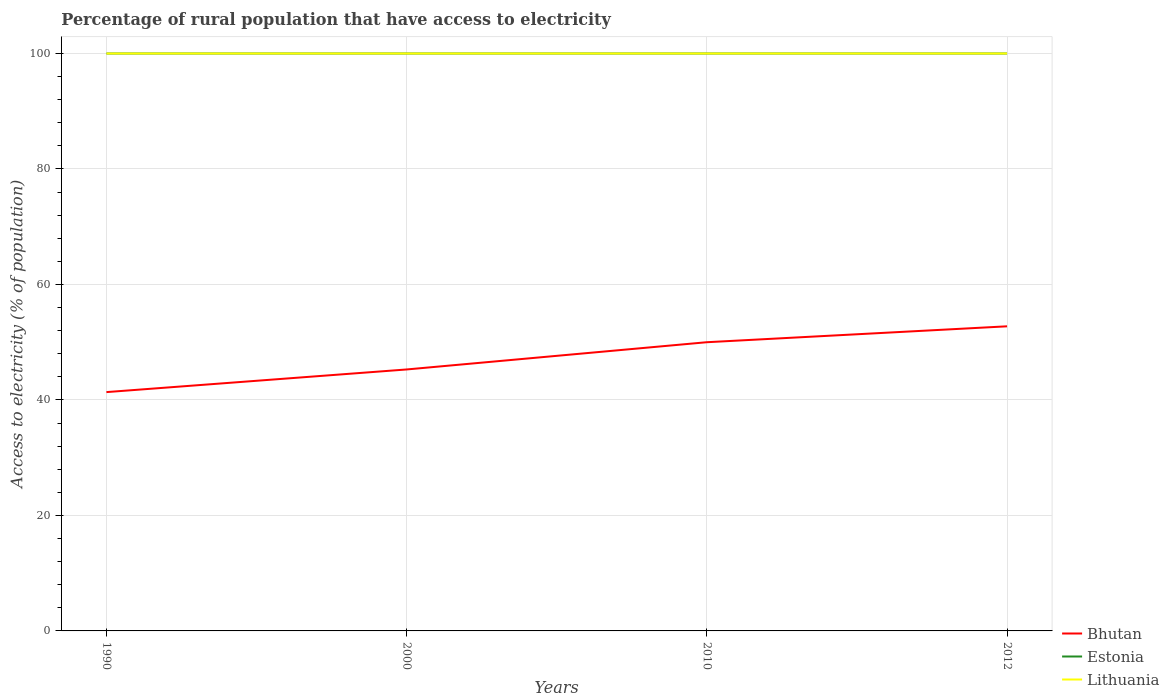Does the line corresponding to Bhutan intersect with the line corresponding to Lithuania?
Ensure brevity in your answer.  No. Across all years, what is the maximum percentage of rural population that have access to electricity in Lithuania?
Make the answer very short. 100. In which year was the percentage of rural population that have access to electricity in Bhutan maximum?
Offer a very short reply. 1990. What is the total percentage of rural population that have access to electricity in Estonia in the graph?
Provide a succinct answer. 0. Is the percentage of rural population that have access to electricity in Lithuania strictly greater than the percentage of rural population that have access to electricity in Bhutan over the years?
Your answer should be very brief. No. How many lines are there?
Make the answer very short. 3. How many years are there in the graph?
Keep it short and to the point. 4. What is the difference between two consecutive major ticks on the Y-axis?
Provide a short and direct response. 20. What is the title of the graph?
Give a very brief answer. Percentage of rural population that have access to electricity. What is the label or title of the X-axis?
Your answer should be very brief. Years. What is the label or title of the Y-axis?
Your answer should be compact. Access to electricity (% of population). What is the Access to electricity (% of population) in Bhutan in 1990?
Offer a very short reply. 41.36. What is the Access to electricity (% of population) in Estonia in 1990?
Make the answer very short. 100. What is the Access to electricity (% of population) of Bhutan in 2000?
Your answer should be compact. 45.28. What is the Access to electricity (% of population) in Lithuania in 2000?
Offer a very short reply. 100. What is the Access to electricity (% of population) in Bhutan in 2010?
Your answer should be compact. 50. What is the Access to electricity (% of population) of Estonia in 2010?
Provide a short and direct response. 100. What is the Access to electricity (% of population) of Bhutan in 2012?
Provide a short and direct response. 52.75. What is the Access to electricity (% of population) in Lithuania in 2012?
Ensure brevity in your answer.  100. Across all years, what is the maximum Access to electricity (% of population) in Bhutan?
Keep it short and to the point. 52.75. Across all years, what is the maximum Access to electricity (% of population) in Lithuania?
Make the answer very short. 100. Across all years, what is the minimum Access to electricity (% of population) in Bhutan?
Provide a succinct answer. 41.36. What is the total Access to electricity (% of population) in Bhutan in the graph?
Your answer should be compact. 189.4. What is the total Access to electricity (% of population) in Estonia in the graph?
Offer a terse response. 400. What is the total Access to electricity (% of population) in Lithuania in the graph?
Offer a terse response. 400. What is the difference between the Access to electricity (% of population) of Bhutan in 1990 and that in 2000?
Make the answer very short. -3.92. What is the difference between the Access to electricity (% of population) in Estonia in 1990 and that in 2000?
Offer a terse response. 0. What is the difference between the Access to electricity (% of population) of Bhutan in 1990 and that in 2010?
Your response must be concise. -8.64. What is the difference between the Access to electricity (% of population) in Estonia in 1990 and that in 2010?
Keep it short and to the point. 0. What is the difference between the Access to electricity (% of population) of Lithuania in 1990 and that in 2010?
Make the answer very short. 0. What is the difference between the Access to electricity (% of population) of Bhutan in 1990 and that in 2012?
Provide a short and direct response. -11.39. What is the difference between the Access to electricity (% of population) in Estonia in 1990 and that in 2012?
Your answer should be very brief. 0. What is the difference between the Access to electricity (% of population) in Bhutan in 2000 and that in 2010?
Your response must be concise. -4.72. What is the difference between the Access to electricity (% of population) in Estonia in 2000 and that in 2010?
Your response must be concise. 0. What is the difference between the Access to electricity (% of population) in Bhutan in 2000 and that in 2012?
Provide a short and direct response. -7.47. What is the difference between the Access to electricity (% of population) of Estonia in 2000 and that in 2012?
Provide a short and direct response. 0. What is the difference between the Access to electricity (% of population) in Lithuania in 2000 and that in 2012?
Your response must be concise. 0. What is the difference between the Access to electricity (% of population) in Bhutan in 2010 and that in 2012?
Ensure brevity in your answer.  -2.75. What is the difference between the Access to electricity (% of population) of Estonia in 2010 and that in 2012?
Your response must be concise. 0. What is the difference between the Access to electricity (% of population) of Lithuania in 2010 and that in 2012?
Keep it short and to the point. 0. What is the difference between the Access to electricity (% of population) in Bhutan in 1990 and the Access to electricity (% of population) in Estonia in 2000?
Make the answer very short. -58.64. What is the difference between the Access to electricity (% of population) in Bhutan in 1990 and the Access to electricity (% of population) in Lithuania in 2000?
Provide a short and direct response. -58.64. What is the difference between the Access to electricity (% of population) of Estonia in 1990 and the Access to electricity (% of population) of Lithuania in 2000?
Your answer should be very brief. 0. What is the difference between the Access to electricity (% of population) of Bhutan in 1990 and the Access to electricity (% of population) of Estonia in 2010?
Offer a very short reply. -58.64. What is the difference between the Access to electricity (% of population) of Bhutan in 1990 and the Access to electricity (% of population) of Lithuania in 2010?
Give a very brief answer. -58.64. What is the difference between the Access to electricity (% of population) of Estonia in 1990 and the Access to electricity (% of population) of Lithuania in 2010?
Your answer should be compact. 0. What is the difference between the Access to electricity (% of population) of Bhutan in 1990 and the Access to electricity (% of population) of Estonia in 2012?
Keep it short and to the point. -58.64. What is the difference between the Access to electricity (% of population) of Bhutan in 1990 and the Access to electricity (% of population) of Lithuania in 2012?
Give a very brief answer. -58.64. What is the difference between the Access to electricity (% of population) of Bhutan in 2000 and the Access to electricity (% of population) of Estonia in 2010?
Offer a terse response. -54.72. What is the difference between the Access to electricity (% of population) in Bhutan in 2000 and the Access to electricity (% of population) in Lithuania in 2010?
Keep it short and to the point. -54.72. What is the difference between the Access to electricity (% of population) in Bhutan in 2000 and the Access to electricity (% of population) in Estonia in 2012?
Give a very brief answer. -54.72. What is the difference between the Access to electricity (% of population) in Bhutan in 2000 and the Access to electricity (% of population) in Lithuania in 2012?
Your answer should be compact. -54.72. What is the difference between the Access to electricity (% of population) in Bhutan in 2010 and the Access to electricity (% of population) in Estonia in 2012?
Your answer should be very brief. -50. What is the average Access to electricity (% of population) of Bhutan per year?
Offer a terse response. 47.35. What is the average Access to electricity (% of population) of Estonia per year?
Offer a very short reply. 100. What is the average Access to electricity (% of population) of Lithuania per year?
Ensure brevity in your answer.  100. In the year 1990, what is the difference between the Access to electricity (% of population) in Bhutan and Access to electricity (% of population) in Estonia?
Offer a terse response. -58.64. In the year 1990, what is the difference between the Access to electricity (% of population) of Bhutan and Access to electricity (% of population) of Lithuania?
Provide a short and direct response. -58.64. In the year 1990, what is the difference between the Access to electricity (% of population) of Estonia and Access to electricity (% of population) of Lithuania?
Give a very brief answer. 0. In the year 2000, what is the difference between the Access to electricity (% of population) of Bhutan and Access to electricity (% of population) of Estonia?
Give a very brief answer. -54.72. In the year 2000, what is the difference between the Access to electricity (% of population) in Bhutan and Access to electricity (% of population) in Lithuania?
Your response must be concise. -54.72. In the year 2000, what is the difference between the Access to electricity (% of population) of Estonia and Access to electricity (% of population) of Lithuania?
Your response must be concise. 0. In the year 2010, what is the difference between the Access to electricity (% of population) in Estonia and Access to electricity (% of population) in Lithuania?
Your answer should be very brief. 0. In the year 2012, what is the difference between the Access to electricity (% of population) in Bhutan and Access to electricity (% of population) in Estonia?
Keep it short and to the point. -47.25. In the year 2012, what is the difference between the Access to electricity (% of population) of Bhutan and Access to electricity (% of population) of Lithuania?
Give a very brief answer. -47.25. What is the ratio of the Access to electricity (% of population) of Bhutan in 1990 to that in 2000?
Provide a short and direct response. 0.91. What is the ratio of the Access to electricity (% of population) of Bhutan in 1990 to that in 2010?
Your answer should be very brief. 0.83. What is the ratio of the Access to electricity (% of population) of Lithuania in 1990 to that in 2010?
Your response must be concise. 1. What is the ratio of the Access to electricity (% of population) of Bhutan in 1990 to that in 2012?
Provide a short and direct response. 0.78. What is the ratio of the Access to electricity (% of population) of Bhutan in 2000 to that in 2010?
Offer a very short reply. 0.91. What is the ratio of the Access to electricity (% of population) of Lithuania in 2000 to that in 2010?
Keep it short and to the point. 1. What is the ratio of the Access to electricity (% of population) of Bhutan in 2000 to that in 2012?
Ensure brevity in your answer.  0.86. What is the ratio of the Access to electricity (% of population) of Lithuania in 2000 to that in 2012?
Keep it short and to the point. 1. What is the ratio of the Access to electricity (% of population) of Bhutan in 2010 to that in 2012?
Provide a succinct answer. 0.95. What is the ratio of the Access to electricity (% of population) of Lithuania in 2010 to that in 2012?
Provide a succinct answer. 1. What is the difference between the highest and the second highest Access to electricity (% of population) of Bhutan?
Offer a terse response. 2.75. What is the difference between the highest and the lowest Access to electricity (% of population) in Bhutan?
Offer a very short reply. 11.39. What is the difference between the highest and the lowest Access to electricity (% of population) of Lithuania?
Your response must be concise. 0. 